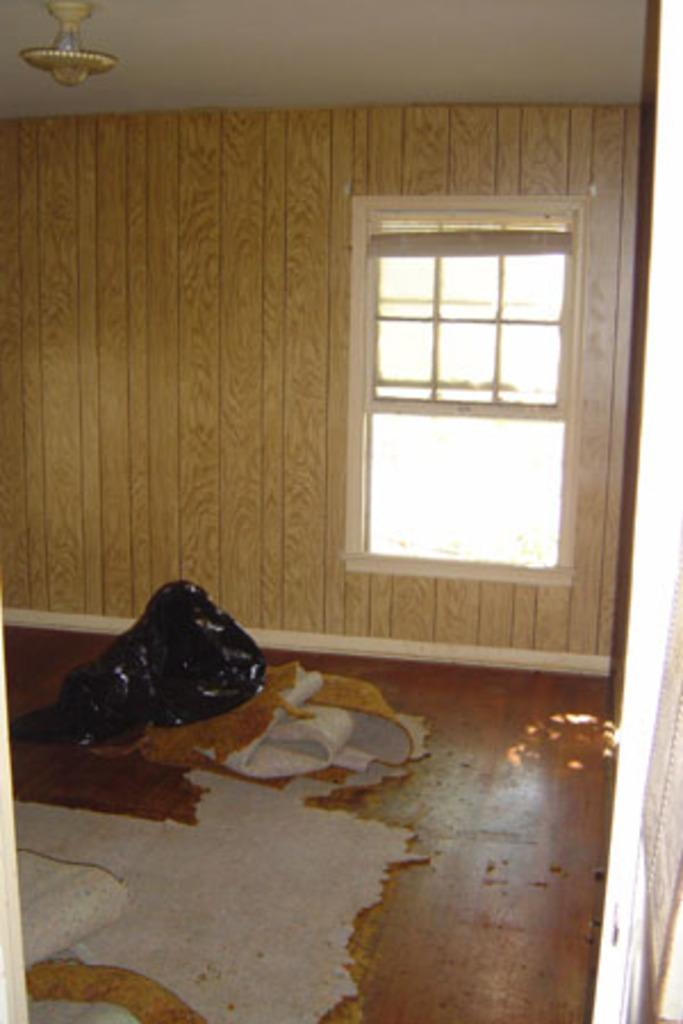What type of structure is located on the right side of the image? There is a glass window on the right side of the image. What is present at the bottom of the image? There is a floor mat at the bottom of the image. What can be seen at the top of the image? There is a light visible at the top of the image. How many hands are visible holding an umbrella in the image? There is no umbrella or hands visible in the image. What type of picture is hanging on the wall in the image? There is no picture hanging on the wall in the image. 